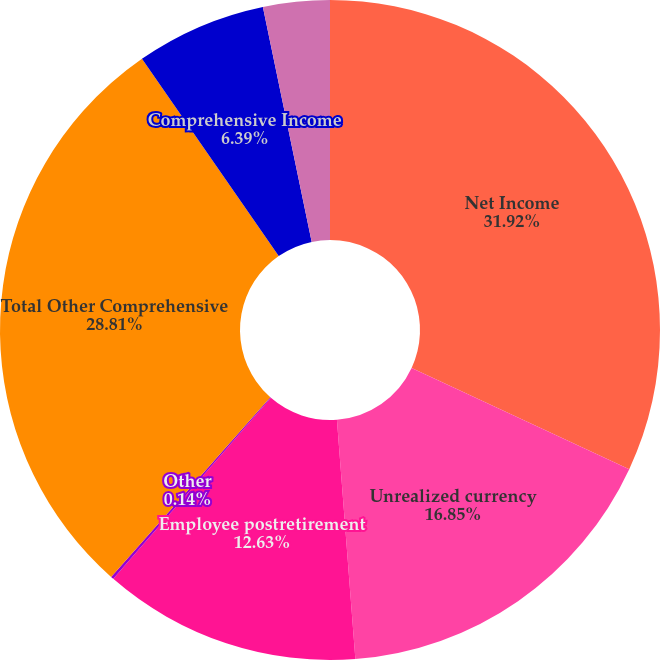Convert chart to OTSL. <chart><loc_0><loc_0><loc_500><loc_500><pie_chart><fcel>Net Income<fcel>Unrealized currency<fcel>Employee postretirement<fcel>Other<fcel>Total Other Comprehensive<fcel>Comprehensive Income<fcel>Comprehensive income<nl><fcel>31.93%<fcel>16.85%<fcel>12.63%<fcel>0.14%<fcel>28.81%<fcel>6.39%<fcel>3.26%<nl></chart> 